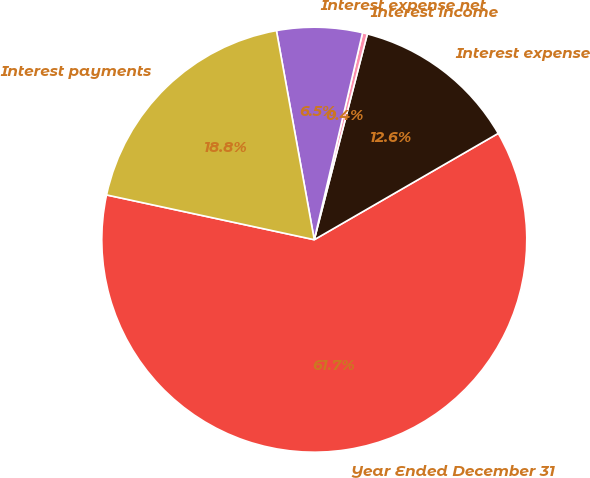Convert chart. <chart><loc_0><loc_0><loc_500><loc_500><pie_chart><fcel>Year Ended December 31<fcel>Interest expense<fcel>Interest income<fcel>Interest expense net<fcel>Interest payments<nl><fcel>61.72%<fcel>12.64%<fcel>0.37%<fcel>6.5%<fcel>18.77%<nl></chart> 